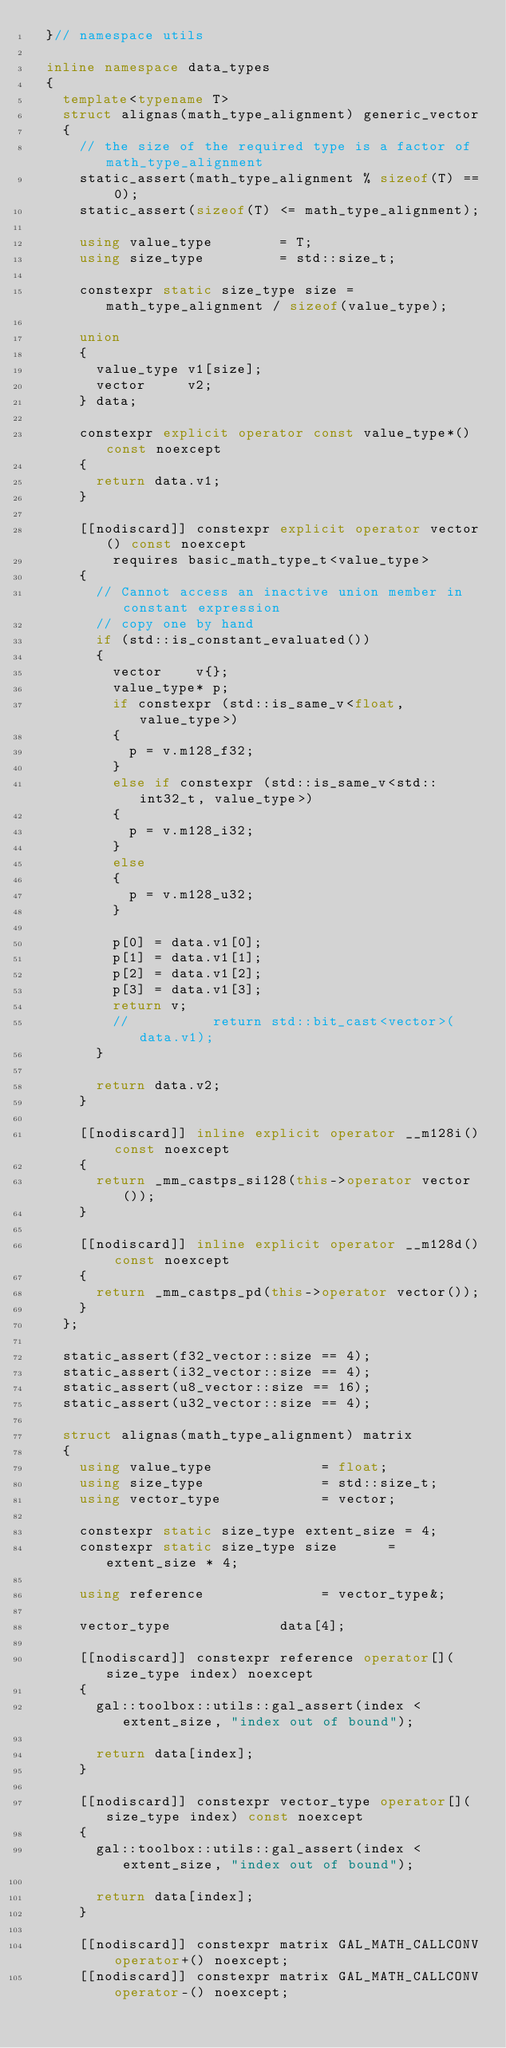Convert code to text. <code><loc_0><loc_0><loc_500><loc_500><_C++_>	}// namespace utils

	inline namespace data_types
	{
		template<typename T>
		struct alignas(math_type_alignment) generic_vector
		{
			// the size of the required type is a factor of math_type_alignment
			static_assert(math_type_alignment % sizeof(T) == 0);
			static_assert(sizeof(T) <= math_type_alignment);

			using value_type				= T;
			using size_type					= std::size_t;

			constexpr static size_type size = math_type_alignment / sizeof(value_type);

			union
			{
				value_type v1[size];
				vector	   v2;
			} data;

			constexpr explicit operator const value_type*() const noexcept
			{
				return data.v1;
			}

			[[nodiscard]] constexpr explicit operator vector() const noexcept
					requires basic_math_type_t<value_type>
			{
				// Cannot access an inactive union member in constant expression
				// copy one by hand
				if (std::is_constant_evaluated())
				{
					vector		v{};
					value_type* p;
					if constexpr (std::is_same_v<float, value_type>)
					{
						p = v.m128_f32;
					}
					else if constexpr (std::is_same_v<std::int32_t, value_type>)
					{
						p = v.m128_i32;
					}
					else
					{
						p = v.m128_u32;
					}

					p[0] = data.v1[0];
					p[1] = data.v1[1];
					p[2] = data.v1[2];
					p[3] = data.v1[3];
					return v;
					//					return std::bit_cast<vector>(data.v1);
				}

				return data.v2;
			}

			[[nodiscard]] inline explicit operator __m128i() const noexcept
			{
				return _mm_castps_si128(this->operator vector());
			}

			[[nodiscard]] inline explicit operator __m128d() const noexcept
			{
				return _mm_castps_pd(this->operator vector());
			}
		};

		static_assert(f32_vector::size == 4);
		static_assert(i32_vector::size == 4);
		static_assert(u8_vector::size == 16);
		static_assert(u32_vector::size == 4);

		struct alignas(math_type_alignment) matrix
		{
			using value_type					   = float;
			using size_type						   = std::size_t;
			using vector_type					   = vector;

			constexpr static size_type extent_size = 4;
			constexpr static size_type size		   = extent_size * 4;

			using reference						   = vector_type&;

			vector_type						  data[4];

			[[nodiscard]] constexpr reference operator[](size_type index) noexcept
			{
				gal::toolbox::utils::gal_assert(index < extent_size, "index out of bound");

				return data[index];
			}

			[[nodiscard]] constexpr vector_type operator[](size_type index) const noexcept
			{
				gal::toolbox::utils::gal_assert(index < extent_size, "index out of bound");

				return data[index];
			}

			[[nodiscard]] constexpr matrix GAL_MATH_CALLCONV operator+() noexcept;
			[[nodiscard]] constexpr matrix GAL_MATH_CALLCONV operator-() noexcept;
</code> 